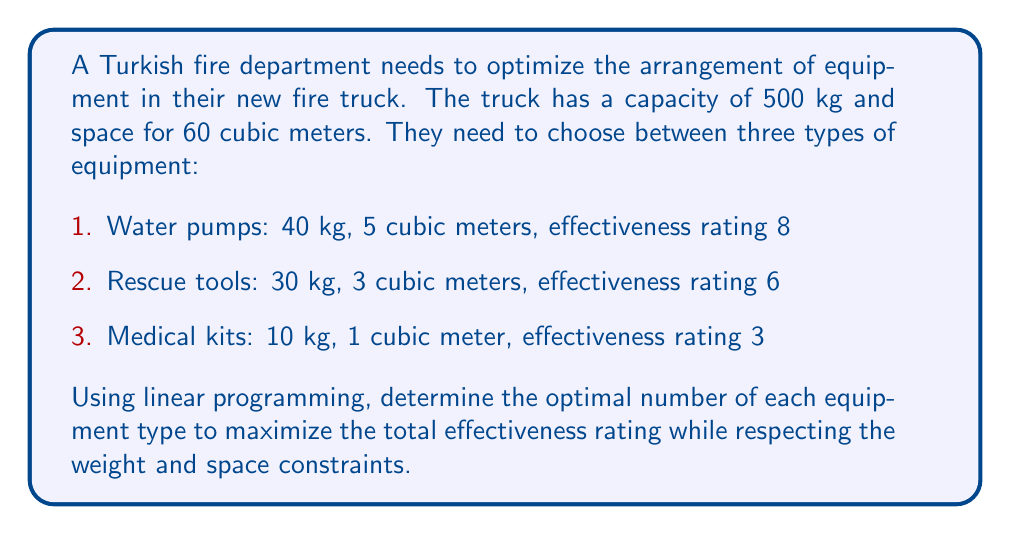Solve this math problem. Let's approach this step-by-step using linear programming:

1. Define variables:
   Let $x_1$ = number of water pumps
   Let $x_2$ = number of rescue tools
   Let $x_3$ = number of medical kits

2. Objective function:
   Maximize $Z = 8x_1 + 6x_2 + 3x_3$

3. Constraints:
   Weight: $40x_1 + 30x_2 + 10x_3 \leq 500$
   Space: $5x_1 + 3x_2 + x_3 \leq 60$
   Non-negativity: $x_1, x_2, x_3 \geq 0$ and integer

4. Set up the linear programming tableau:

   $$
   \begin{array}{c|ccc|c}
     & x_1 & x_2 & x_3 & RHS \\
   \hline
   Z & -8 & -6 & -3 & 0 \\
   s_1 & 40 & 30 & 10 & 500 \\
   s_2 & 5 & 3 & 1 & 60 \\
   \end{array}
   $$

5. Solve using the simplex method (or a linear programming solver).

6. The optimal solution is:
   $x_1 = 8$ (water pumps)
   $x_2 = 6$ (rescue tools)
   $x_3 = 12$ (medical kits)

7. Verify constraints:
   Weight: $40(8) + 30(6) + 10(12) = 500$ kg (meets limit)
   Space: $5(8) + 3(6) + 1(12) = 58$ cubic meters (within limit)

8. Calculate maximum effectiveness:
   $Z = 8(8) + 6(6) + 3(12) = 100$

Therefore, the optimal arrangement is 8 water pumps, 6 rescue tools, and 12 medical kits, achieving a maximum effectiveness rating of 100.
Answer: 8 water pumps, 6 rescue tools, 12 medical kits 